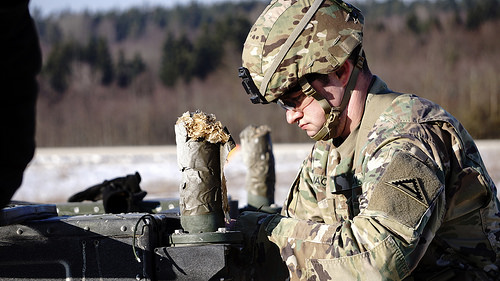<image>
Can you confirm if the patch is behind the machine? No. The patch is not behind the machine. From this viewpoint, the patch appears to be positioned elsewhere in the scene. 